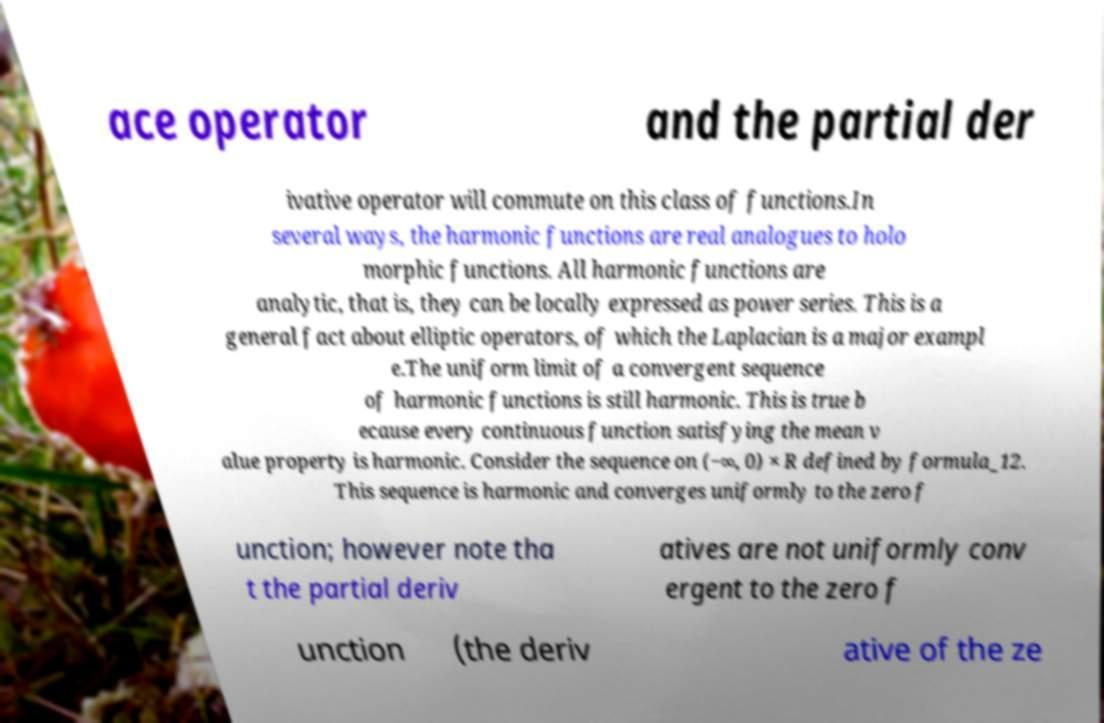Please identify and transcribe the text found in this image. ace operator and the partial der ivative operator will commute on this class of functions.In several ways, the harmonic functions are real analogues to holo morphic functions. All harmonic functions are analytic, that is, they can be locally expressed as power series. This is a general fact about elliptic operators, of which the Laplacian is a major exampl e.The uniform limit of a convergent sequence of harmonic functions is still harmonic. This is true b ecause every continuous function satisfying the mean v alue property is harmonic. Consider the sequence on (−∞, 0) × R defined by formula_12. This sequence is harmonic and converges uniformly to the zero f unction; however note tha t the partial deriv atives are not uniformly conv ergent to the zero f unction (the deriv ative of the ze 